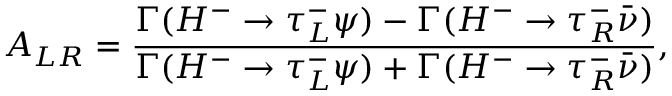<formula> <loc_0><loc_0><loc_500><loc_500>A _ { L R } = \frac { \Gamma ( H ^ { - } \rightarrow \tau _ { L } ^ { - } \psi ) - \Gamma ( H ^ { - } \rightarrow \tau _ { R } ^ { - } \bar { \nu } ) } { \Gamma ( H ^ { - } \rightarrow \tau _ { L } ^ { - } \psi ) + \Gamma ( H ^ { - } \rightarrow \tau _ { R } ^ { - } \bar { \nu } ) } ,</formula> 